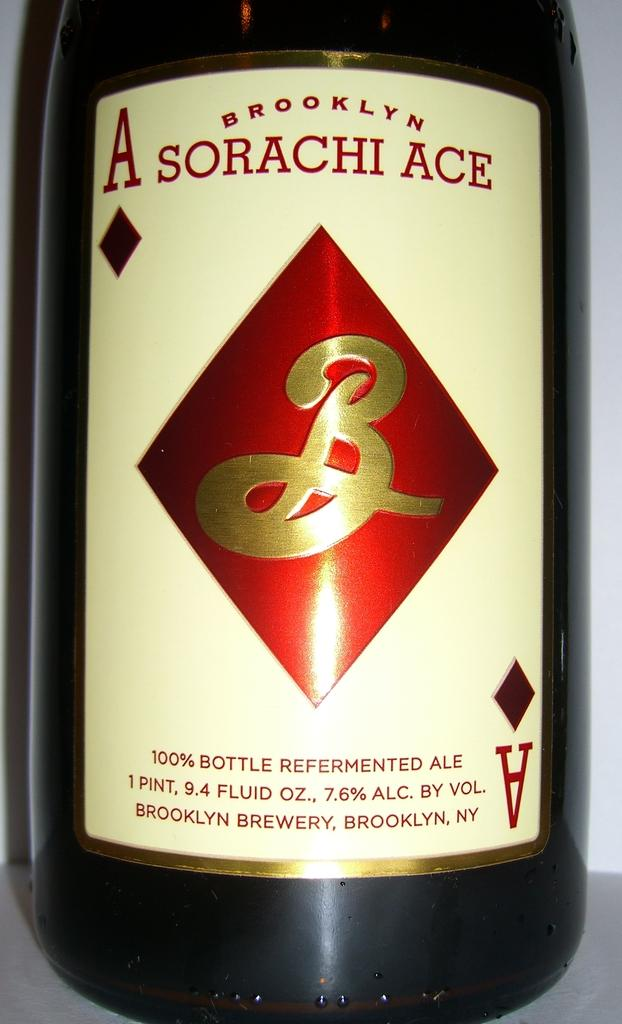<image>
Give a short and clear explanation of the subsequent image. A bottle of Brooklyn Sorachi Ace ale has an ace of diamonds on the label. 